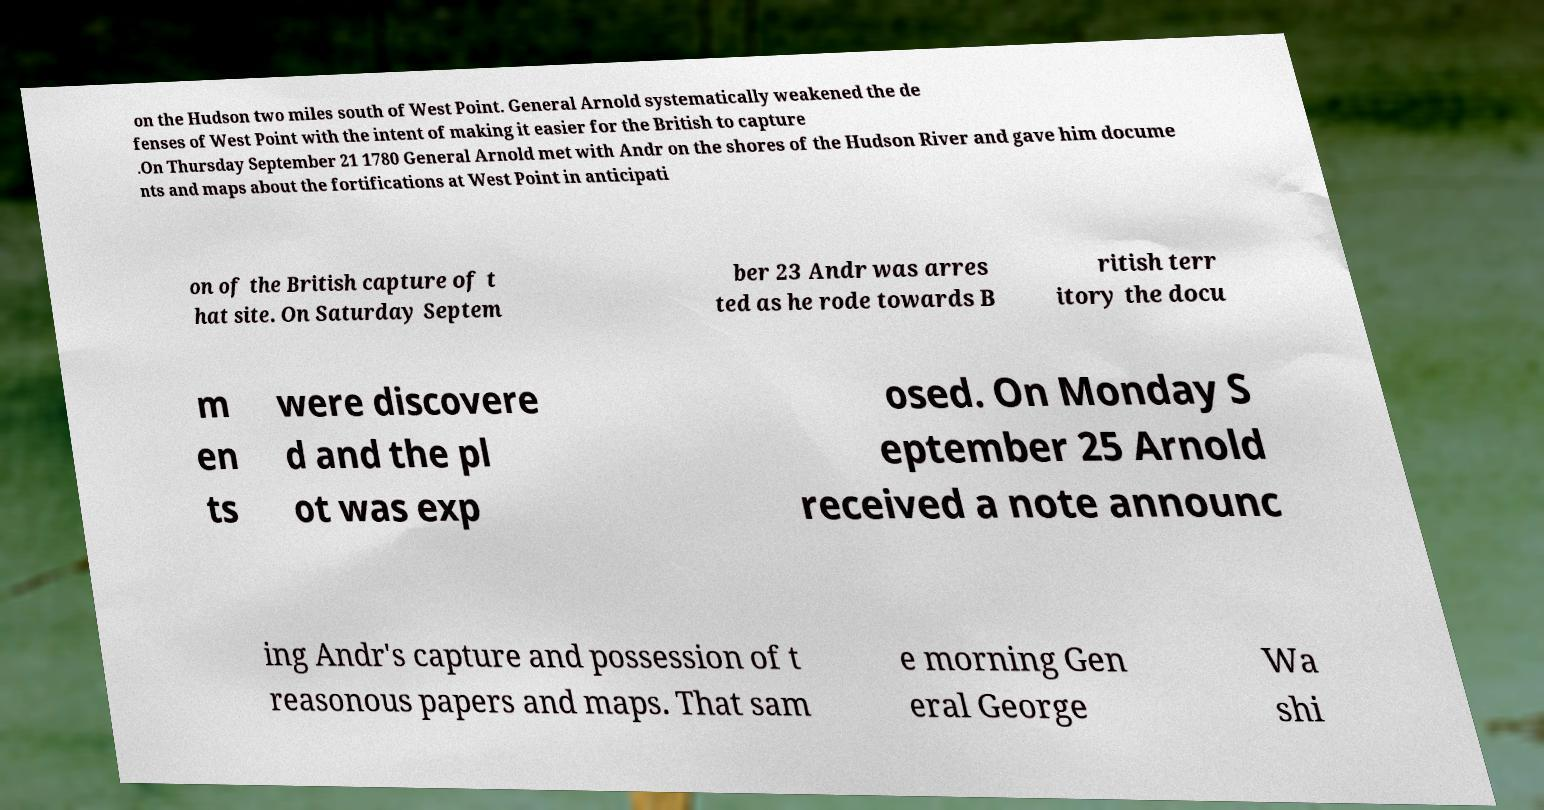Can you accurately transcribe the text from the provided image for me? on the Hudson two miles south of West Point. General Arnold systematically weakened the de fenses of West Point with the intent of making it easier for the British to capture .On Thursday September 21 1780 General Arnold met with Andr on the shores of the Hudson River and gave him docume nts and maps about the fortifications at West Point in anticipati on of the British capture of t hat site. On Saturday Septem ber 23 Andr was arres ted as he rode towards B ritish terr itory the docu m en ts were discovere d and the pl ot was exp osed. On Monday S eptember 25 Arnold received a note announc ing Andr's capture and possession of t reasonous papers and maps. That sam e morning Gen eral George Wa shi 